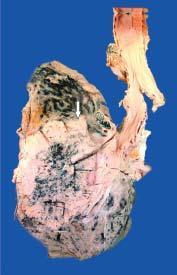does the kidney show grey-white fleshy tumour in the bronchus at its bifurcation?
Answer the question using a single word or phrase. No 